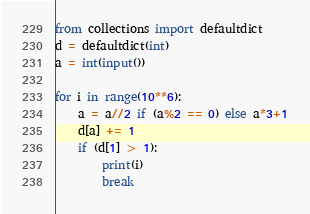Convert code to text. <code><loc_0><loc_0><loc_500><loc_500><_Python_>from collections import defaultdict
d = defaultdict(int)
a = int(input())

for i in range(10**6):
    a = a//2 if (a%2 == 0) else a*3+1
    d[a] += 1
    if (d[1] > 1):
        print(i)
        break
</code> 